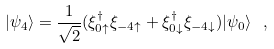<formula> <loc_0><loc_0><loc_500><loc_500>| \psi _ { 4 } \rangle = \frac { 1 } { \sqrt { 2 } } ( \xi ^ { \dagger } _ { 0 \uparrow } \xi _ { - 4 \uparrow } + \xi ^ { \dagger } _ { 0 \downarrow } \xi _ { - 4 \downarrow } ) | \psi _ { 0 } \rangle \ ,</formula> 